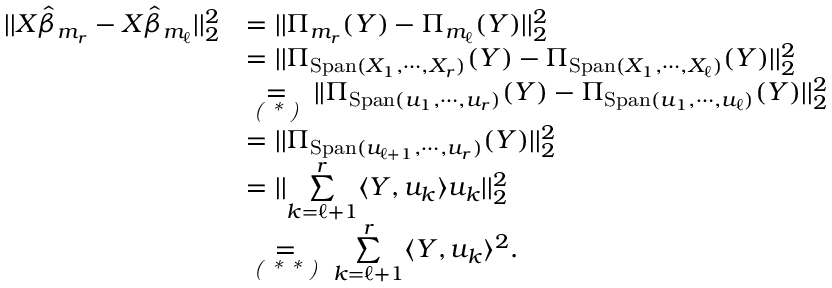<formula> <loc_0><loc_0><loc_500><loc_500>\begin{array} { r l } { | | X \hat { \beta } _ { m _ { r } } - X \hat { \beta } _ { m _ { \ell } } | | _ { 2 } ^ { 2 } } & { = | | \Pi _ { m _ { r } } ( Y ) - \Pi _ { m _ { \ell } } ( Y ) | | _ { 2 } ^ { 2 } } \\ & { = | | \Pi _ { S p a n ( X _ { 1 } , \cdots , X _ { r } ) } ( Y ) - \Pi _ { S p a n ( X _ { 1 } , \cdots , X _ { \ell } ) } ( Y ) | | _ { 2 } ^ { 2 } } \\ & { \underset { ( * ) } { = } | | \Pi _ { S p a n ( u _ { 1 } , \cdots , u _ { r } ) } ( Y ) - \Pi _ { S p a n ( u _ { 1 } , \cdots , u _ { \ell } ) } ( Y ) | | _ { 2 } ^ { 2 } } \\ & { = | | \Pi _ { S p a n ( u _ { \ell + 1 } , \cdots , u _ { r } ) } ( Y ) | | _ { 2 } ^ { 2 } } \\ & { = | | \underset { k = \ell + 1 } { \overset { r } { \sum } } \langle Y , u _ { k } \rangle u _ { k } | | _ { 2 } ^ { 2 } } \\ & { \underset { ( * * ) } { = } \underset { k = \ell + 1 } { \overset { r } { \sum } } \langle Y , u _ { k } \rangle ^ { 2 } . } \end{array}</formula> 